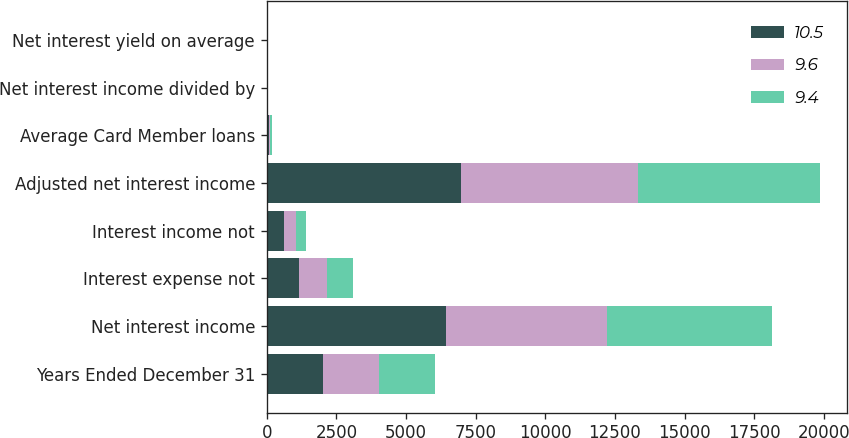Convert chart to OTSL. <chart><loc_0><loc_0><loc_500><loc_500><stacked_bar_chart><ecel><fcel>Years Ended December 31<fcel>Net interest income<fcel>Interest expense not<fcel>Interest income not<fcel>Adjusted net interest income<fcel>Average Card Member loans<fcel>Net interest income divided by<fcel>Net interest yield on average<nl><fcel>10.5<fcel>2017<fcel>6441<fcel>1170<fcel>636<fcel>6975<fcel>66.7<fcel>9.7<fcel>10.5<nl><fcel>9.6<fcel>2016<fcel>5771<fcel>984<fcel>403<fcel>6352<fcel>65.8<fcel>8.8<fcel>9.6<nl><fcel>9.4<fcel>2015<fcel>5922<fcel>952<fcel>357<fcel>6517<fcel>69<fcel>8.6<fcel>9.4<nl></chart> 